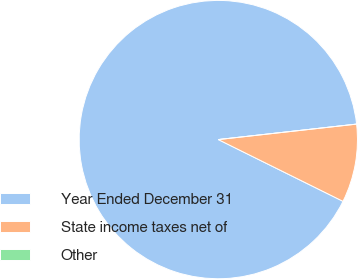Convert chart. <chart><loc_0><loc_0><loc_500><loc_500><pie_chart><fcel>Year Ended December 31<fcel>State income taxes net of<fcel>Other<nl><fcel>90.9%<fcel>9.09%<fcel>0.0%<nl></chart> 